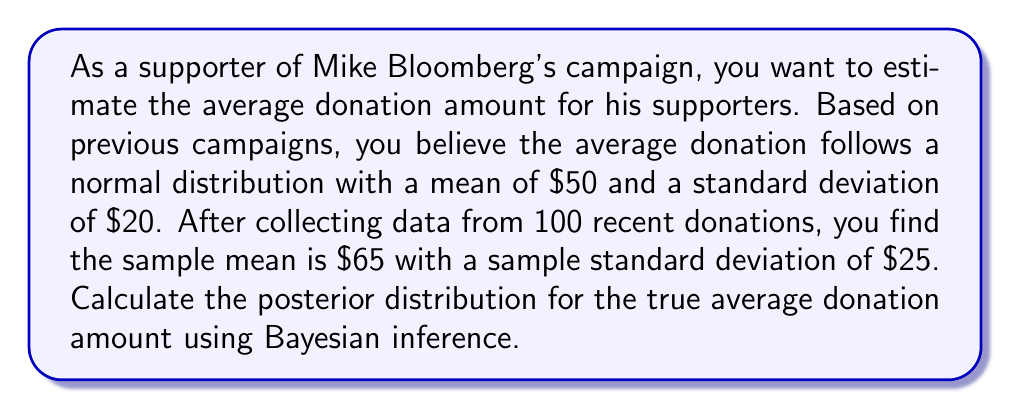Could you help me with this problem? To solve this problem, we'll use Bayesian inference to update our prior beliefs about the average donation amount given the new data. We'll assume that the variance is known and use conjugate priors for simplicity.

Given:
- Prior distribution: $\mu \sim N(50, 20^2)$
- Sample data: $n = 100$, $\bar{x} = 65$, $s = 25$

Step 1: Set up the prior distribution
Prior mean: $\mu_0 = 50$
Prior variance: $\sigma_0^2 = 20^2 = 400$

Step 2: Calculate the likelihood
Likelihood variance: $\sigma^2 = s^2 = 25^2 = 625$
Likelihood precision: $\tau = \frac{n}{\sigma^2} = \frac{100}{625} = 0.16$

Step 3: Calculate the posterior distribution parameters
Posterior precision: $\tau_n = \frac{1}{\sigma_0^2} + \tau = \frac{1}{400} + 0.16 = 0.1625$
Posterior variance: $\sigma_n^2 = \frac{1}{\tau_n} = \frac{1}{0.1625} \approx 6.15$

Posterior mean:
$$\mu_n = \frac{\frac{\mu_0}{\sigma_0^2} + \tau\bar{x}}{\tau_n} = \frac{\frac{50}{400} + 0.16 \cdot 65}{0.1625} \approx 62.31$$

Step 4: Write the posterior distribution
The posterior distribution for the true average donation amount is:

$$\mu | \text{data} \sim N(62.31, 6.15)$$

This means that after updating our prior beliefs with the new data, we now believe the average donation amount follows a normal distribution with a mean of $62.31 and a variance of $6.15 (standard deviation of about $2.48).
Answer: The posterior distribution for the true average donation amount is $N(62.31, 6.15)$. 